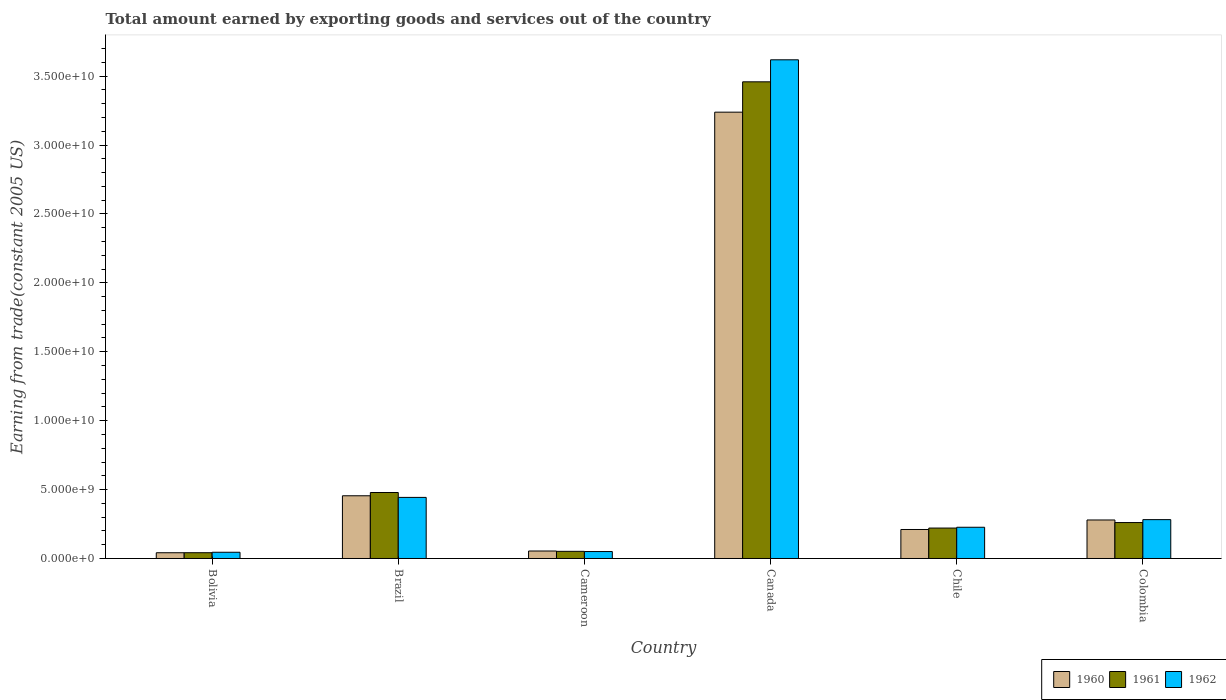Are the number of bars on each tick of the X-axis equal?
Ensure brevity in your answer.  Yes. In how many cases, is the number of bars for a given country not equal to the number of legend labels?
Give a very brief answer. 0. What is the total amount earned by exporting goods and services in 1961 in Colombia?
Offer a very short reply. 2.61e+09. Across all countries, what is the maximum total amount earned by exporting goods and services in 1961?
Make the answer very short. 3.46e+1. Across all countries, what is the minimum total amount earned by exporting goods and services in 1962?
Your answer should be very brief. 4.52e+08. What is the total total amount earned by exporting goods and services in 1960 in the graph?
Your response must be concise. 4.28e+1. What is the difference between the total amount earned by exporting goods and services in 1962 in Brazil and that in Chile?
Provide a succinct answer. 2.17e+09. What is the difference between the total amount earned by exporting goods and services in 1961 in Brazil and the total amount earned by exporting goods and services in 1962 in Bolivia?
Give a very brief answer. 4.33e+09. What is the average total amount earned by exporting goods and services in 1961 per country?
Offer a terse response. 7.52e+09. What is the difference between the total amount earned by exporting goods and services of/in 1962 and total amount earned by exporting goods and services of/in 1960 in Bolivia?
Offer a terse response. 3.55e+07. What is the ratio of the total amount earned by exporting goods and services in 1961 in Cameroon to that in Canada?
Make the answer very short. 0.02. Is the total amount earned by exporting goods and services in 1961 in Cameroon less than that in Chile?
Offer a very short reply. Yes. What is the difference between the highest and the second highest total amount earned by exporting goods and services in 1960?
Ensure brevity in your answer.  -2.96e+1. What is the difference between the highest and the lowest total amount earned by exporting goods and services in 1962?
Provide a succinct answer. 3.57e+1. Is the sum of the total amount earned by exporting goods and services in 1962 in Brazil and Canada greater than the maximum total amount earned by exporting goods and services in 1961 across all countries?
Provide a short and direct response. Yes. What does the 1st bar from the right in Bolivia represents?
Offer a terse response. 1962. Are all the bars in the graph horizontal?
Your response must be concise. No. Are the values on the major ticks of Y-axis written in scientific E-notation?
Offer a terse response. Yes. Does the graph contain grids?
Provide a succinct answer. No. Where does the legend appear in the graph?
Your answer should be very brief. Bottom right. How many legend labels are there?
Provide a short and direct response. 3. How are the legend labels stacked?
Give a very brief answer. Horizontal. What is the title of the graph?
Provide a succinct answer. Total amount earned by exporting goods and services out of the country. What is the label or title of the X-axis?
Give a very brief answer. Country. What is the label or title of the Y-axis?
Provide a short and direct response. Earning from trade(constant 2005 US). What is the Earning from trade(constant 2005 US) in 1960 in Bolivia?
Ensure brevity in your answer.  4.17e+08. What is the Earning from trade(constant 2005 US) of 1961 in Bolivia?
Your response must be concise. 4.19e+08. What is the Earning from trade(constant 2005 US) of 1962 in Bolivia?
Offer a terse response. 4.52e+08. What is the Earning from trade(constant 2005 US) in 1960 in Brazil?
Provide a short and direct response. 4.55e+09. What is the Earning from trade(constant 2005 US) in 1961 in Brazil?
Provide a succinct answer. 4.79e+09. What is the Earning from trade(constant 2005 US) in 1962 in Brazil?
Your response must be concise. 4.43e+09. What is the Earning from trade(constant 2005 US) in 1960 in Cameroon?
Your response must be concise. 5.42e+08. What is the Earning from trade(constant 2005 US) in 1961 in Cameroon?
Give a very brief answer. 5.19e+08. What is the Earning from trade(constant 2005 US) of 1962 in Cameroon?
Offer a terse response. 5.04e+08. What is the Earning from trade(constant 2005 US) of 1960 in Canada?
Your answer should be very brief. 3.24e+1. What is the Earning from trade(constant 2005 US) of 1961 in Canada?
Your answer should be compact. 3.46e+1. What is the Earning from trade(constant 2005 US) in 1962 in Canada?
Ensure brevity in your answer.  3.62e+1. What is the Earning from trade(constant 2005 US) in 1960 in Chile?
Give a very brief answer. 2.10e+09. What is the Earning from trade(constant 2005 US) in 1961 in Chile?
Your response must be concise. 2.21e+09. What is the Earning from trade(constant 2005 US) of 1962 in Chile?
Provide a succinct answer. 2.27e+09. What is the Earning from trade(constant 2005 US) in 1960 in Colombia?
Keep it short and to the point. 2.79e+09. What is the Earning from trade(constant 2005 US) in 1961 in Colombia?
Your response must be concise. 2.61e+09. What is the Earning from trade(constant 2005 US) of 1962 in Colombia?
Offer a terse response. 2.82e+09. Across all countries, what is the maximum Earning from trade(constant 2005 US) of 1960?
Provide a succinct answer. 3.24e+1. Across all countries, what is the maximum Earning from trade(constant 2005 US) in 1961?
Offer a very short reply. 3.46e+1. Across all countries, what is the maximum Earning from trade(constant 2005 US) in 1962?
Make the answer very short. 3.62e+1. Across all countries, what is the minimum Earning from trade(constant 2005 US) in 1960?
Your answer should be very brief. 4.17e+08. Across all countries, what is the minimum Earning from trade(constant 2005 US) of 1961?
Your response must be concise. 4.19e+08. Across all countries, what is the minimum Earning from trade(constant 2005 US) of 1962?
Provide a short and direct response. 4.52e+08. What is the total Earning from trade(constant 2005 US) in 1960 in the graph?
Your answer should be compact. 4.28e+1. What is the total Earning from trade(constant 2005 US) in 1961 in the graph?
Keep it short and to the point. 4.51e+1. What is the total Earning from trade(constant 2005 US) in 1962 in the graph?
Your response must be concise. 4.67e+1. What is the difference between the Earning from trade(constant 2005 US) of 1960 in Bolivia and that in Brazil?
Your answer should be compact. -4.13e+09. What is the difference between the Earning from trade(constant 2005 US) in 1961 in Bolivia and that in Brazil?
Your response must be concise. -4.37e+09. What is the difference between the Earning from trade(constant 2005 US) of 1962 in Bolivia and that in Brazil?
Provide a succinct answer. -3.98e+09. What is the difference between the Earning from trade(constant 2005 US) of 1960 in Bolivia and that in Cameroon?
Provide a short and direct response. -1.26e+08. What is the difference between the Earning from trade(constant 2005 US) of 1961 in Bolivia and that in Cameroon?
Your response must be concise. -1.00e+08. What is the difference between the Earning from trade(constant 2005 US) in 1962 in Bolivia and that in Cameroon?
Make the answer very short. -5.20e+07. What is the difference between the Earning from trade(constant 2005 US) of 1960 in Bolivia and that in Canada?
Your response must be concise. -3.20e+1. What is the difference between the Earning from trade(constant 2005 US) in 1961 in Bolivia and that in Canada?
Give a very brief answer. -3.42e+1. What is the difference between the Earning from trade(constant 2005 US) in 1962 in Bolivia and that in Canada?
Offer a terse response. -3.57e+1. What is the difference between the Earning from trade(constant 2005 US) of 1960 in Bolivia and that in Chile?
Ensure brevity in your answer.  -1.69e+09. What is the difference between the Earning from trade(constant 2005 US) of 1961 in Bolivia and that in Chile?
Your response must be concise. -1.79e+09. What is the difference between the Earning from trade(constant 2005 US) of 1962 in Bolivia and that in Chile?
Provide a short and direct response. -1.81e+09. What is the difference between the Earning from trade(constant 2005 US) in 1960 in Bolivia and that in Colombia?
Your answer should be compact. -2.38e+09. What is the difference between the Earning from trade(constant 2005 US) of 1961 in Bolivia and that in Colombia?
Provide a succinct answer. -2.19e+09. What is the difference between the Earning from trade(constant 2005 US) of 1962 in Bolivia and that in Colombia?
Ensure brevity in your answer.  -2.37e+09. What is the difference between the Earning from trade(constant 2005 US) of 1960 in Brazil and that in Cameroon?
Make the answer very short. 4.01e+09. What is the difference between the Earning from trade(constant 2005 US) of 1961 in Brazil and that in Cameroon?
Your answer should be very brief. 4.27e+09. What is the difference between the Earning from trade(constant 2005 US) in 1962 in Brazil and that in Cameroon?
Your answer should be very brief. 3.93e+09. What is the difference between the Earning from trade(constant 2005 US) of 1960 in Brazil and that in Canada?
Offer a terse response. -2.78e+1. What is the difference between the Earning from trade(constant 2005 US) in 1961 in Brazil and that in Canada?
Give a very brief answer. -2.98e+1. What is the difference between the Earning from trade(constant 2005 US) in 1962 in Brazil and that in Canada?
Offer a very short reply. -3.18e+1. What is the difference between the Earning from trade(constant 2005 US) in 1960 in Brazil and that in Chile?
Offer a very short reply. 2.45e+09. What is the difference between the Earning from trade(constant 2005 US) in 1961 in Brazil and that in Chile?
Offer a very short reply. 2.58e+09. What is the difference between the Earning from trade(constant 2005 US) of 1962 in Brazil and that in Chile?
Your answer should be compact. 2.17e+09. What is the difference between the Earning from trade(constant 2005 US) in 1960 in Brazil and that in Colombia?
Your answer should be very brief. 1.76e+09. What is the difference between the Earning from trade(constant 2005 US) in 1961 in Brazil and that in Colombia?
Provide a short and direct response. 2.18e+09. What is the difference between the Earning from trade(constant 2005 US) in 1962 in Brazil and that in Colombia?
Your answer should be very brief. 1.61e+09. What is the difference between the Earning from trade(constant 2005 US) of 1960 in Cameroon and that in Canada?
Make the answer very short. -3.18e+1. What is the difference between the Earning from trade(constant 2005 US) of 1961 in Cameroon and that in Canada?
Your response must be concise. -3.41e+1. What is the difference between the Earning from trade(constant 2005 US) in 1962 in Cameroon and that in Canada?
Your answer should be compact. -3.57e+1. What is the difference between the Earning from trade(constant 2005 US) in 1960 in Cameroon and that in Chile?
Your answer should be compact. -1.56e+09. What is the difference between the Earning from trade(constant 2005 US) of 1961 in Cameroon and that in Chile?
Keep it short and to the point. -1.69e+09. What is the difference between the Earning from trade(constant 2005 US) in 1962 in Cameroon and that in Chile?
Provide a short and direct response. -1.76e+09. What is the difference between the Earning from trade(constant 2005 US) of 1960 in Cameroon and that in Colombia?
Your answer should be very brief. -2.25e+09. What is the difference between the Earning from trade(constant 2005 US) in 1961 in Cameroon and that in Colombia?
Your answer should be very brief. -2.09e+09. What is the difference between the Earning from trade(constant 2005 US) in 1962 in Cameroon and that in Colombia?
Give a very brief answer. -2.31e+09. What is the difference between the Earning from trade(constant 2005 US) in 1960 in Canada and that in Chile?
Your answer should be compact. 3.03e+1. What is the difference between the Earning from trade(constant 2005 US) of 1961 in Canada and that in Chile?
Provide a short and direct response. 3.24e+1. What is the difference between the Earning from trade(constant 2005 US) of 1962 in Canada and that in Chile?
Ensure brevity in your answer.  3.39e+1. What is the difference between the Earning from trade(constant 2005 US) in 1960 in Canada and that in Colombia?
Ensure brevity in your answer.  2.96e+1. What is the difference between the Earning from trade(constant 2005 US) of 1961 in Canada and that in Colombia?
Offer a very short reply. 3.20e+1. What is the difference between the Earning from trade(constant 2005 US) in 1962 in Canada and that in Colombia?
Offer a terse response. 3.34e+1. What is the difference between the Earning from trade(constant 2005 US) in 1960 in Chile and that in Colombia?
Offer a terse response. -6.89e+08. What is the difference between the Earning from trade(constant 2005 US) in 1961 in Chile and that in Colombia?
Your answer should be compact. -3.99e+08. What is the difference between the Earning from trade(constant 2005 US) of 1962 in Chile and that in Colombia?
Make the answer very short. -5.53e+08. What is the difference between the Earning from trade(constant 2005 US) of 1960 in Bolivia and the Earning from trade(constant 2005 US) of 1961 in Brazil?
Make the answer very short. -4.37e+09. What is the difference between the Earning from trade(constant 2005 US) of 1960 in Bolivia and the Earning from trade(constant 2005 US) of 1962 in Brazil?
Make the answer very short. -4.02e+09. What is the difference between the Earning from trade(constant 2005 US) in 1961 in Bolivia and the Earning from trade(constant 2005 US) in 1962 in Brazil?
Keep it short and to the point. -4.01e+09. What is the difference between the Earning from trade(constant 2005 US) of 1960 in Bolivia and the Earning from trade(constant 2005 US) of 1961 in Cameroon?
Ensure brevity in your answer.  -1.03e+08. What is the difference between the Earning from trade(constant 2005 US) in 1960 in Bolivia and the Earning from trade(constant 2005 US) in 1962 in Cameroon?
Offer a terse response. -8.75e+07. What is the difference between the Earning from trade(constant 2005 US) of 1961 in Bolivia and the Earning from trade(constant 2005 US) of 1962 in Cameroon?
Provide a succinct answer. -8.51e+07. What is the difference between the Earning from trade(constant 2005 US) in 1960 in Bolivia and the Earning from trade(constant 2005 US) in 1961 in Canada?
Offer a very short reply. -3.42e+1. What is the difference between the Earning from trade(constant 2005 US) in 1960 in Bolivia and the Earning from trade(constant 2005 US) in 1962 in Canada?
Give a very brief answer. -3.58e+1. What is the difference between the Earning from trade(constant 2005 US) of 1961 in Bolivia and the Earning from trade(constant 2005 US) of 1962 in Canada?
Ensure brevity in your answer.  -3.58e+1. What is the difference between the Earning from trade(constant 2005 US) in 1960 in Bolivia and the Earning from trade(constant 2005 US) in 1961 in Chile?
Provide a succinct answer. -1.79e+09. What is the difference between the Earning from trade(constant 2005 US) of 1960 in Bolivia and the Earning from trade(constant 2005 US) of 1962 in Chile?
Ensure brevity in your answer.  -1.85e+09. What is the difference between the Earning from trade(constant 2005 US) of 1961 in Bolivia and the Earning from trade(constant 2005 US) of 1962 in Chile?
Provide a short and direct response. -1.85e+09. What is the difference between the Earning from trade(constant 2005 US) in 1960 in Bolivia and the Earning from trade(constant 2005 US) in 1961 in Colombia?
Offer a terse response. -2.19e+09. What is the difference between the Earning from trade(constant 2005 US) in 1960 in Bolivia and the Earning from trade(constant 2005 US) in 1962 in Colombia?
Offer a very short reply. -2.40e+09. What is the difference between the Earning from trade(constant 2005 US) of 1961 in Bolivia and the Earning from trade(constant 2005 US) of 1962 in Colombia?
Provide a succinct answer. -2.40e+09. What is the difference between the Earning from trade(constant 2005 US) of 1960 in Brazil and the Earning from trade(constant 2005 US) of 1961 in Cameroon?
Your response must be concise. 4.03e+09. What is the difference between the Earning from trade(constant 2005 US) in 1960 in Brazil and the Earning from trade(constant 2005 US) in 1962 in Cameroon?
Make the answer very short. 4.05e+09. What is the difference between the Earning from trade(constant 2005 US) of 1961 in Brazil and the Earning from trade(constant 2005 US) of 1962 in Cameroon?
Provide a succinct answer. 4.28e+09. What is the difference between the Earning from trade(constant 2005 US) in 1960 in Brazil and the Earning from trade(constant 2005 US) in 1961 in Canada?
Keep it short and to the point. -3.00e+1. What is the difference between the Earning from trade(constant 2005 US) in 1960 in Brazil and the Earning from trade(constant 2005 US) in 1962 in Canada?
Keep it short and to the point. -3.16e+1. What is the difference between the Earning from trade(constant 2005 US) in 1961 in Brazil and the Earning from trade(constant 2005 US) in 1962 in Canada?
Your answer should be compact. -3.14e+1. What is the difference between the Earning from trade(constant 2005 US) of 1960 in Brazil and the Earning from trade(constant 2005 US) of 1961 in Chile?
Offer a very short reply. 2.34e+09. What is the difference between the Earning from trade(constant 2005 US) in 1960 in Brazil and the Earning from trade(constant 2005 US) in 1962 in Chile?
Offer a terse response. 2.28e+09. What is the difference between the Earning from trade(constant 2005 US) in 1961 in Brazil and the Earning from trade(constant 2005 US) in 1962 in Chile?
Your response must be concise. 2.52e+09. What is the difference between the Earning from trade(constant 2005 US) of 1960 in Brazil and the Earning from trade(constant 2005 US) of 1961 in Colombia?
Your answer should be very brief. 1.94e+09. What is the difference between the Earning from trade(constant 2005 US) of 1960 in Brazil and the Earning from trade(constant 2005 US) of 1962 in Colombia?
Your response must be concise. 1.73e+09. What is the difference between the Earning from trade(constant 2005 US) in 1961 in Brazil and the Earning from trade(constant 2005 US) in 1962 in Colombia?
Ensure brevity in your answer.  1.97e+09. What is the difference between the Earning from trade(constant 2005 US) in 1960 in Cameroon and the Earning from trade(constant 2005 US) in 1961 in Canada?
Give a very brief answer. -3.40e+1. What is the difference between the Earning from trade(constant 2005 US) of 1960 in Cameroon and the Earning from trade(constant 2005 US) of 1962 in Canada?
Ensure brevity in your answer.  -3.56e+1. What is the difference between the Earning from trade(constant 2005 US) in 1961 in Cameroon and the Earning from trade(constant 2005 US) in 1962 in Canada?
Provide a succinct answer. -3.57e+1. What is the difference between the Earning from trade(constant 2005 US) in 1960 in Cameroon and the Earning from trade(constant 2005 US) in 1961 in Chile?
Provide a short and direct response. -1.67e+09. What is the difference between the Earning from trade(constant 2005 US) in 1960 in Cameroon and the Earning from trade(constant 2005 US) in 1962 in Chile?
Provide a short and direct response. -1.72e+09. What is the difference between the Earning from trade(constant 2005 US) of 1961 in Cameroon and the Earning from trade(constant 2005 US) of 1962 in Chile?
Provide a short and direct response. -1.75e+09. What is the difference between the Earning from trade(constant 2005 US) in 1960 in Cameroon and the Earning from trade(constant 2005 US) in 1961 in Colombia?
Your answer should be very brief. -2.07e+09. What is the difference between the Earning from trade(constant 2005 US) in 1960 in Cameroon and the Earning from trade(constant 2005 US) in 1962 in Colombia?
Provide a short and direct response. -2.28e+09. What is the difference between the Earning from trade(constant 2005 US) of 1961 in Cameroon and the Earning from trade(constant 2005 US) of 1962 in Colombia?
Offer a very short reply. -2.30e+09. What is the difference between the Earning from trade(constant 2005 US) in 1960 in Canada and the Earning from trade(constant 2005 US) in 1961 in Chile?
Make the answer very short. 3.02e+1. What is the difference between the Earning from trade(constant 2005 US) of 1960 in Canada and the Earning from trade(constant 2005 US) of 1962 in Chile?
Ensure brevity in your answer.  3.01e+1. What is the difference between the Earning from trade(constant 2005 US) in 1961 in Canada and the Earning from trade(constant 2005 US) in 1962 in Chile?
Your answer should be compact. 3.23e+1. What is the difference between the Earning from trade(constant 2005 US) in 1960 in Canada and the Earning from trade(constant 2005 US) in 1961 in Colombia?
Your response must be concise. 2.98e+1. What is the difference between the Earning from trade(constant 2005 US) of 1960 in Canada and the Earning from trade(constant 2005 US) of 1962 in Colombia?
Your answer should be compact. 2.96e+1. What is the difference between the Earning from trade(constant 2005 US) of 1961 in Canada and the Earning from trade(constant 2005 US) of 1962 in Colombia?
Offer a very short reply. 3.18e+1. What is the difference between the Earning from trade(constant 2005 US) in 1960 in Chile and the Earning from trade(constant 2005 US) in 1961 in Colombia?
Keep it short and to the point. -5.03e+08. What is the difference between the Earning from trade(constant 2005 US) of 1960 in Chile and the Earning from trade(constant 2005 US) of 1962 in Colombia?
Your response must be concise. -7.14e+08. What is the difference between the Earning from trade(constant 2005 US) in 1961 in Chile and the Earning from trade(constant 2005 US) in 1962 in Colombia?
Your answer should be very brief. -6.10e+08. What is the average Earning from trade(constant 2005 US) of 1960 per country?
Give a very brief answer. 7.13e+09. What is the average Earning from trade(constant 2005 US) of 1961 per country?
Offer a terse response. 7.52e+09. What is the average Earning from trade(constant 2005 US) in 1962 per country?
Your answer should be very brief. 7.78e+09. What is the difference between the Earning from trade(constant 2005 US) of 1960 and Earning from trade(constant 2005 US) of 1961 in Bolivia?
Ensure brevity in your answer.  -2.45e+06. What is the difference between the Earning from trade(constant 2005 US) in 1960 and Earning from trade(constant 2005 US) in 1962 in Bolivia?
Keep it short and to the point. -3.55e+07. What is the difference between the Earning from trade(constant 2005 US) in 1961 and Earning from trade(constant 2005 US) in 1962 in Bolivia?
Provide a short and direct response. -3.30e+07. What is the difference between the Earning from trade(constant 2005 US) of 1960 and Earning from trade(constant 2005 US) of 1961 in Brazil?
Offer a very short reply. -2.36e+08. What is the difference between the Earning from trade(constant 2005 US) of 1960 and Earning from trade(constant 2005 US) of 1962 in Brazil?
Keep it short and to the point. 1.18e+08. What is the difference between the Earning from trade(constant 2005 US) of 1961 and Earning from trade(constant 2005 US) of 1962 in Brazil?
Give a very brief answer. 3.55e+08. What is the difference between the Earning from trade(constant 2005 US) in 1960 and Earning from trade(constant 2005 US) in 1961 in Cameroon?
Keep it short and to the point. 2.31e+07. What is the difference between the Earning from trade(constant 2005 US) of 1960 and Earning from trade(constant 2005 US) of 1962 in Cameroon?
Give a very brief answer. 3.82e+07. What is the difference between the Earning from trade(constant 2005 US) in 1961 and Earning from trade(constant 2005 US) in 1962 in Cameroon?
Offer a terse response. 1.51e+07. What is the difference between the Earning from trade(constant 2005 US) of 1960 and Earning from trade(constant 2005 US) of 1961 in Canada?
Give a very brief answer. -2.20e+09. What is the difference between the Earning from trade(constant 2005 US) of 1960 and Earning from trade(constant 2005 US) of 1962 in Canada?
Ensure brevity in your answer.  -3.80e+09. What is the difference between the Earning from trade(constant 2005 US) in 1961 and Earning from trade(constant 2005 US) in 1962 in Canada?
Make the answer very short. -1.60e+09. What is the difference between the Earning from trade(constant 2005 US) of 1960 and Earning from trade(constant 2005 US) of 1961 in Chile?
Offer a terse response. -1.04e+08. What is the difference between the Earning from trade(constant 2005 US) in 1960 and Earning from trade(constant 2005 US) in 1962 in Chile?
Provide a short and direct response. -1.62e+08. What is the difference between the Earning from trade(constant 2005 US) in 1961 and Earning from trade(constant 2005 US) in 1962 in Chile?
Give a very brief answer. -5.76e+07. What is the difference between the Earning from trade(constant 2005 US) in 1960 and Earning from trade(constant 2005 US) in 1961 in Colombia?
Your response must be concise. 1.86e+08. What is the difference between the Earning from trade(constant 2005 US) in 1960 and Earning from trade(constant 2005 US) in 1962 in Colombia?
Offer a terse response. -2.49e+07. What is the difference between the Earning from trade(constant 2005 US) in 1961 and Earning from trade(constant 2005 US) in 1962 in Colombia?
Ensure brevity in your answer.  -2.11e+08. What is the ratio of the Earning from trade(constant 2005 US) of 1960 in Bolivia to that in Brazil?
Your answer should be compact. 0.09. What is the ratio of the Earning from trade(constant 2005 US) of 1961 in Bolivia to that in Brazil?
Your response must be concise. 0.09. What is the ratio of the Earning from trade(constant 2005 US) in 1962 in Bolivia to that in Brazil?
Your answer should be compact. 0.1. What is the ratio of the Earning from trade(constant 2005 US) of 1960 in Bolivia to that in Cameroon?
Your answer should be very brief. 0.77. What is the ratio of the Earning from trade(constant 2005 US) of 1961 in Bolivia to that in Cameroon?
Make the answer very short. 0.81. What is the ratio of the Earning from trade(constant 2005 US) in 1962 in Bolivia to that in Cameroon?
Provide a succinct answer. 0.9. What is the ratio of the Earning from trade(constant 2005 US) in 1960 in Bolivia to that in Canada?
Offer a very short reply. 0.01. What is the ratio of the Earning from trade(constant 2005 US) of 1961 in Bolivia to that in Canada?
Provide a succinct answer. 0.01. What is the ratio of the Earning from trade(constant 2005 US) in 1962 in Bolivia to that in Canada?
Your answer should be very brief. 0.01. What is the ratio of the Earning from trade(constant 2005 US) in 1960 in Bolivia to that in Chile?
Your answer should be compact. 0.2. What is the ratio of the Earning from trade(constant 2005 US) in 1961 in Bolivia to that in Chile?
Provide a succinct answer. 0.19. What is the ratio of the Earning from trade(constant 2005 US) in 1962 in Bolivia to that in Chile?
Offer a very short reply. 0.2. What is the ratio of the Earning from trade(constant 2005 US) in 1960 in Bolivia to that in Colombia?
Keep it short and to the point. 0.15. What is the ratio of the Earning from trade(constant 2005 US) in 1961 in Bolivia to that in Colombia?
Ensure brevity in your answer.  0.16. What is the ratio of the Earning from trade(constant 2005 US) of 1962 in Bolivia to that in Colombia?
Offer a very short reply. 0.16. What is the ratio of the Earning from trade(constant 2005 US) in 1960 in Brazil to that in Cameroon?
Provide a succinct answer. 8.39. What is the ratio of the Earning from trade(constant 2005 US) of 1961 in Brazil to that in Cameroon?
Keep it short and to the point. 9.22. What is the ratio of the Earning from trade(constant 2005 US) of 1962 in Brazil to that in Cameroon?
Give a very brief answer. 8.79. What is the ratio of the Earning from trade(constant 2005 US) of 1960 in Brazil to that in Canada?
Give a very brief answer. 0.14. What is the ratio of the Earning from trade(constant 2005 US) of 1961 in Brazil to that in Canada?
Make the answer very short. 0.14. What is the ratio of the Earning from trade(constant 2005 US) of 1962 in Brazil to that in Canada?
Your response must be concise. 0.12. What is the ratio of the Earning from trade(constant 2005 US) of 1960 in Brazil to that in Chile?
Provide a short and direct response. 2.16. What is the ratio of the Earning from trade(constant 2005 US) in 1961 in Brazil to that in Chile?
Make the answer very short. 2.17. What is the ratio of the Earning from trade(constant 2005 US) of 1962 in Brazil to that in Chile?
Give a very brief answer. 1.96. What is the ratio of the Earning from trade(constant 2005 US) in 1960 in Brazil to that in Colombia?
Give a very brief answer. 1.63. What is the ratio of the Earning from trade(constant 2005 US) in 1961 in Brazil to that in Colombia?
Offer a very short reply. 1.84. What is the ratio of the Earning from trade(constant 2005 US) in 1962 in Brazil to that in Colombia?
Your answer should be very brief. 1.57. What is the ratio of the Earning from trade(constant 2005 US) in 1960 in Cameroon to that in Canada?
Make the answer very short. 0.02. What is the ratio of the Earning from trade(constant 2005 US) in 1961 in Cameroon to that in Canada?
Give a very brief answer. 0.01. What is the ratio of the Earning from trade(constant 2005 US) of 1962 in Cameroon to that in Canada?
Keep it short and to the point. 0.01. What is the ratio of the Earning from trade(constant 2005 US) of 1960 in Cameroon to that in Chile?
Your response must be concise. 0.26. What is the ratio of the Earning from trade(constant 2005 US) in 1961 in Cameroon to that in Chile?
Your answer should be very brief. 0.24. What is the ratio of the Earning from trade(constant 2005 US) in 1962 in Cameroon to that in Chile?
Make the answer very short. 0.22. What is the ratio of the Earning from trade(constant 2005 US) of 1960 in Cameroon to that in Colombia?
Provide a succinct answer. 0.19. What is the ratio of the Earning from trade(constant 2005 US) of 1961 in Cameroon to that in Colombia?
Offer a terse response. 0.2. What is the ratio of the Earning from trade(constant 2005 US) in 1962 in Cameroon to that in Colombia?
Your answer should be compact. 0.18. What is the ratio of the Earning from trade(constant 2005 US) of 1960 in Canada to that in Chile?
Your answer should be compact. 15.39. What is the ratio of the Earning from trade(constant 2005 US) in 1961 in Canada to that in Chile?
Provide a succinct answer. 15.66. What is the ratio of the Earning from trade(constant 2005 US) in 1962 in Canada to that in Chile?
Make the answer very short. 15.97. What is the ratio of the Earning from trade(constant 2005 US) of 1960 in Canada to that in Colombia?
Your answer should be very brief. 11.59. What is the ratio of the Earning from trade(constant 2005 US) of 1961 in Canada to that in Colombia?
Offer a terse response. 13.26. What is the ratio of the Earning from trade(constant 2005 US) of 1962 in Canada to that in Colombia?
Make the answer very short. 12.84. What is the ratio of the Earning from trade(constant 2005 US) in 1960 in Chile to that in Colombia?
Keep it short and to the point. 0.75. What is the ratio of the Earning from trade(constant 2005 US) of 1961 in Chile to that in Colombia?
Make the answer very short. 0.85. What is the ratio of the Earning from trade(constant 2005 US) in 1962 in Chile to that in Colombia?
Keep it short and to the point. 0.8. What is the difference between the highest and the second highest Earning from trade(constant 2005 US) of 1960?
Keep it short and to the point. 2.78e+1. What is the difference between the highest and the second highest Earning from trade(constant 2005 US) in 1961?
Offer a terse response. 2.98e+1. What is the difference between the highest and the second highest Earning from trade(constant 2005 US) of 1962?
Ensure brevity in your answer.  3.18e+1. What is the difference between the highest and the lowest Earning from trade(constant 2005 US) of 1960?
Give a very brief answer. 3.20e+1. What is the difference between the highest and the lowest Earning from trade(constant 2005 US) of 1961?
Your response must be concise. 3.42e+1. What is the difference between the highest and the lowest Earning from trade(constant 2005 US) of 1962?
Make the answer very short. 3.57e+1. 